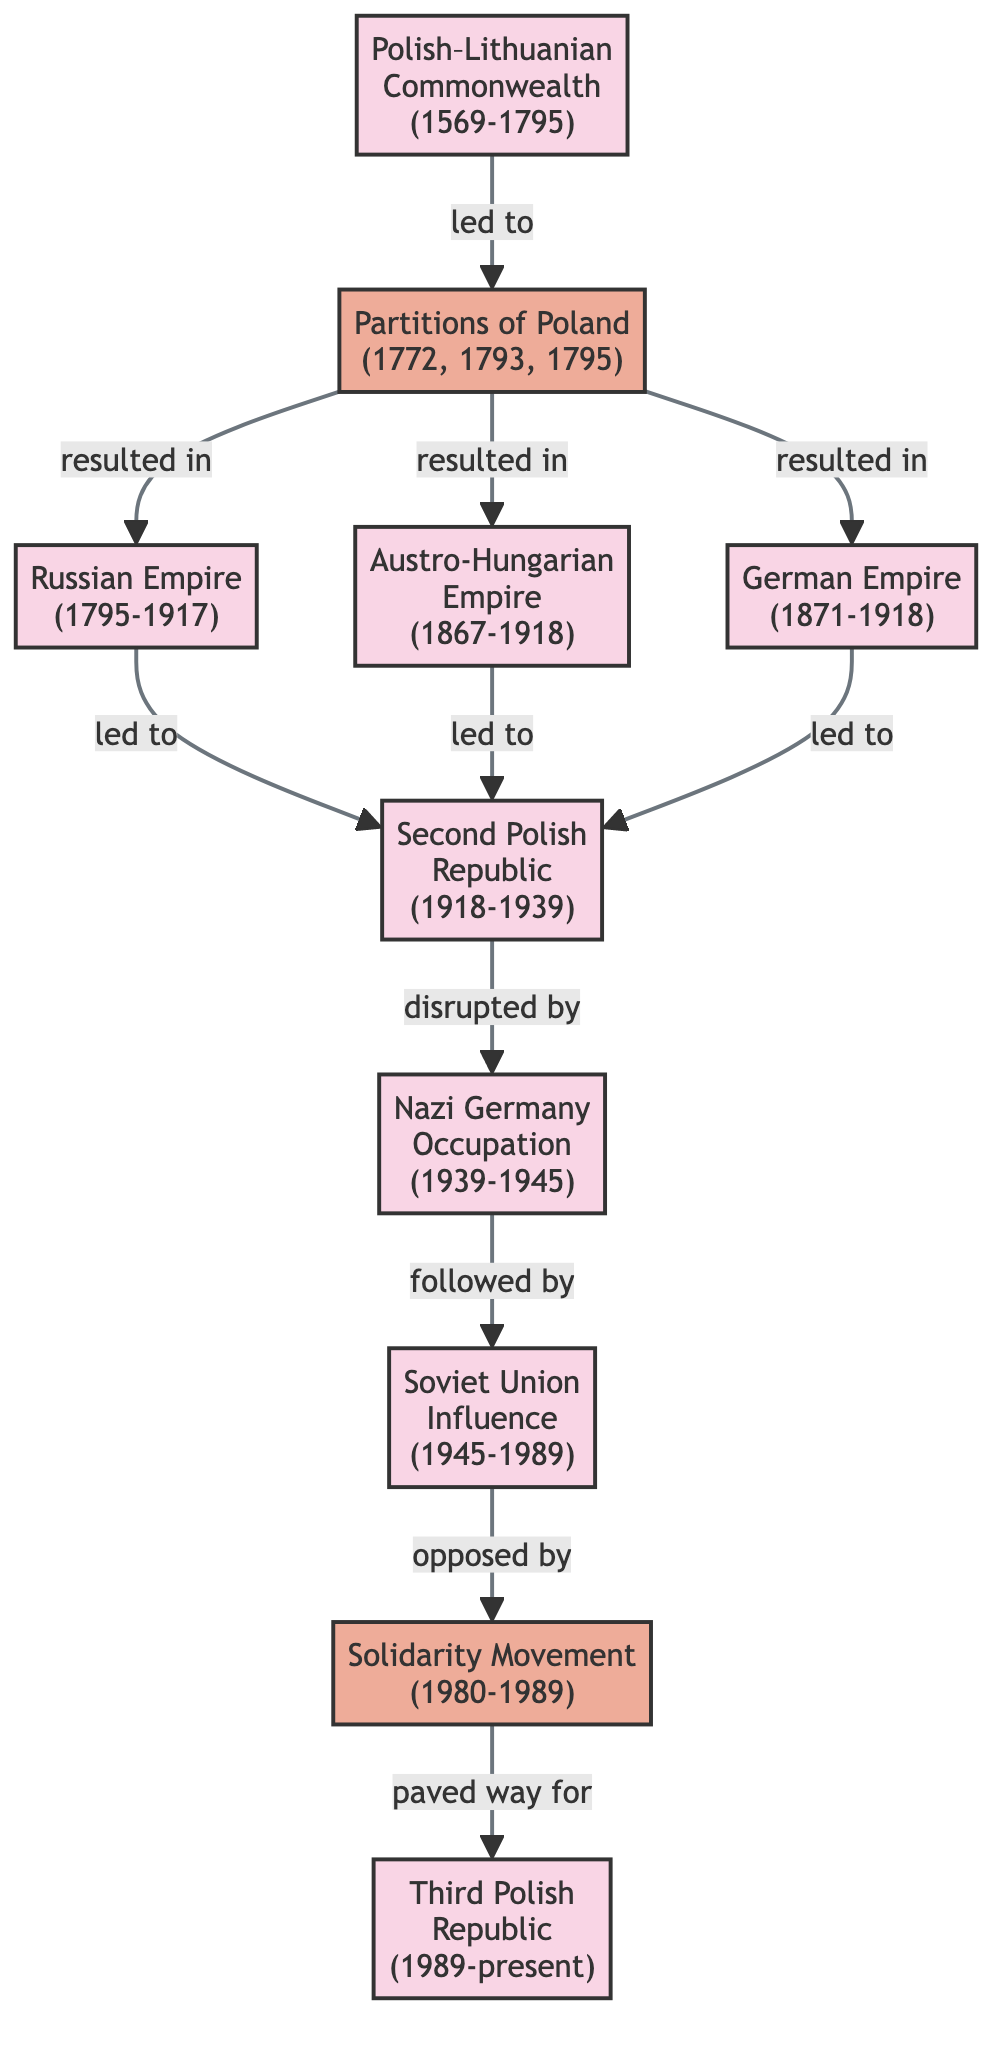What political regime led to the Partitions of Poland? The diagram indicates a direct connection from the "Polish–Lithuanian Commonwealth" to the "Partitions of Poland," showing that it was the regime that led to the partitions.
Answer: Polish–Lithuanian Commonwealth How many political regimes are represented in the diagram? By counting the nodes categorized as "political_regime," I find that there are 8 regimes listed: Polish–Lithuanian Commonwealth, Russian Empire, Austro-Hungarian Empire, German Empire, Second Polish Republic, Nazi Germany Occupation, Soviet Union Influence, and Third Polish Republic.
Answer: 8 Which political regime disrupted the Second Polish Republic? The edge between the "Second Polish Republic" and "Nazi Germany Occupation" shows that the latter disrupted the former, indicating that it was the regime that caused the disruption.
Answer: Nazi Germany Occupation What event followed the Nazi Germany Occupation? The diagram shows a direct relationship where the "Nazi Germany Occupation" is followed by "Soviet Union Influence," making it clear that the Soviet influence came next in this timeline.
Answer: Soviet Union Influence Which two political regimes led to the Second Polish Republic? The edges show that both the "Russian Empire" and the "Austro-Hungarian Empire" led to the "Second Polish Republic," demonstrating a transformation from these regimes to the republic.
Answer: Russian Empire, Austro-Hungarian Empire What is the relationship between the Solidarity Movement and the Third Polish Republic? According to the diagram, the "Solidarity Movement" paved the way for the "Third Polish Republic," indicating a direct link where the movement was significant for the emergence of the new republic.
Answer: Paved way for How many events are depicted in the diagram? By assessing the nodes categorized as "political_event," I determine there are 3 events represented: Partitions of Poland, Solidarity Movement, and their respective relationships with the political regimes.
Answer: 3 What was the result of the Partitions of Poland? The diagram illustrates that the "Partitions of Poland" resulted in three political regimes—the "Russian Empire," "Austro-Hungarian Empire," and "German Empire," indicating its multifaceted consequences.
Answer: Russian Empire, Austro-Hungarian Empire, German Empire Which political regime directly opposed the Soviet Union Influence? The diagram indicates a direct opposition between "Soviet Union Influence" and the "Solidarity Movement," showing that the movement worked against the influence of the Soviet regime during its period.
Answer: Solidarity Movement 